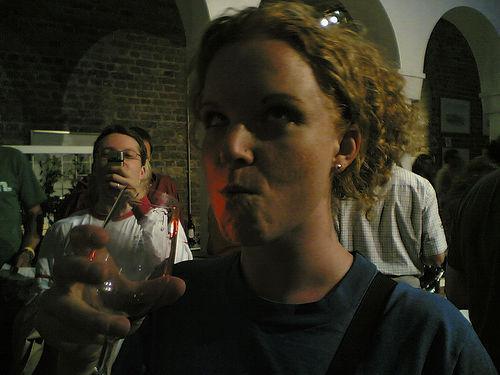How many people are there?
Give a very brief answer. 5. 